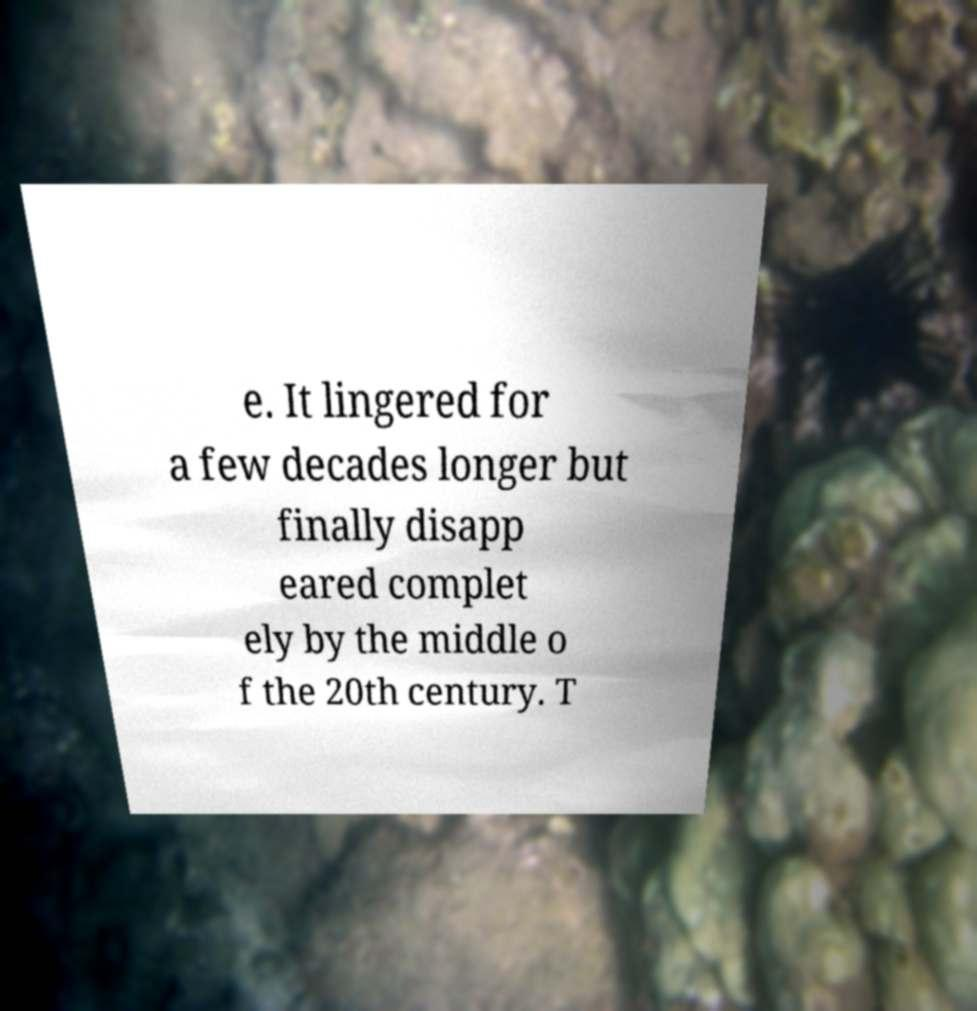There's text embedded in this image that I need extracted. Can you transcribe it verbatim? e. It lingered for a few decades longer but finally disapp eared complet ely by the middle o f the 20th century. T 